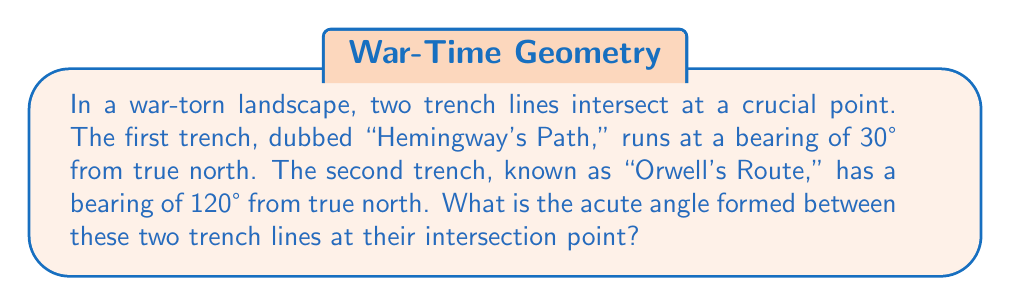Teach me how to tackle this problem. To solve this problem, we'll follow these steps:

1) First, we need to understand that the angle between the trench lines is not simply the difference between their bearings. The bearing is measured from true north, so we need to consider how these angles relate to each other.

2) Let's visualize the problem:

   [asy]
   import geometry;
   
   size(200);
   
   draw((0,0)--(0,100),arrow=Arrow(TeXHead));
   draw((0,0)--(86.6,50),arrow=Arrow(TeXHead));
   draw((0,0)--(-86.6,-50),arrow=Arrow(TeXHead));
   
   label("N", (0,110));
   label("Hemingway's Path", (95,55));
   label("Orwell's Route", (-95,-55));
   label("30°", (20,40));
   label("120°", (-20,-40));
   label("$\theta$", (-40,20));
   
   dot((0,0));
   [/asy]

3) The angle we're looking for, let's call it $\theta$, is the acute angle between these two lines.

4) We can find this angle by subtracting the smaller bearing from the larger bearing:

   $\theta = 120° - 30° = 90°$

5) However, we need to check if this is the acute angle. In this case, 90° is not acute (it's a right angle), so we need to find its complement:

   Acute angle $= 180° - 90° = 90°$

6) Therefore, the acute angle between the two trench lines is indeed 90°.
Answer: 90° 